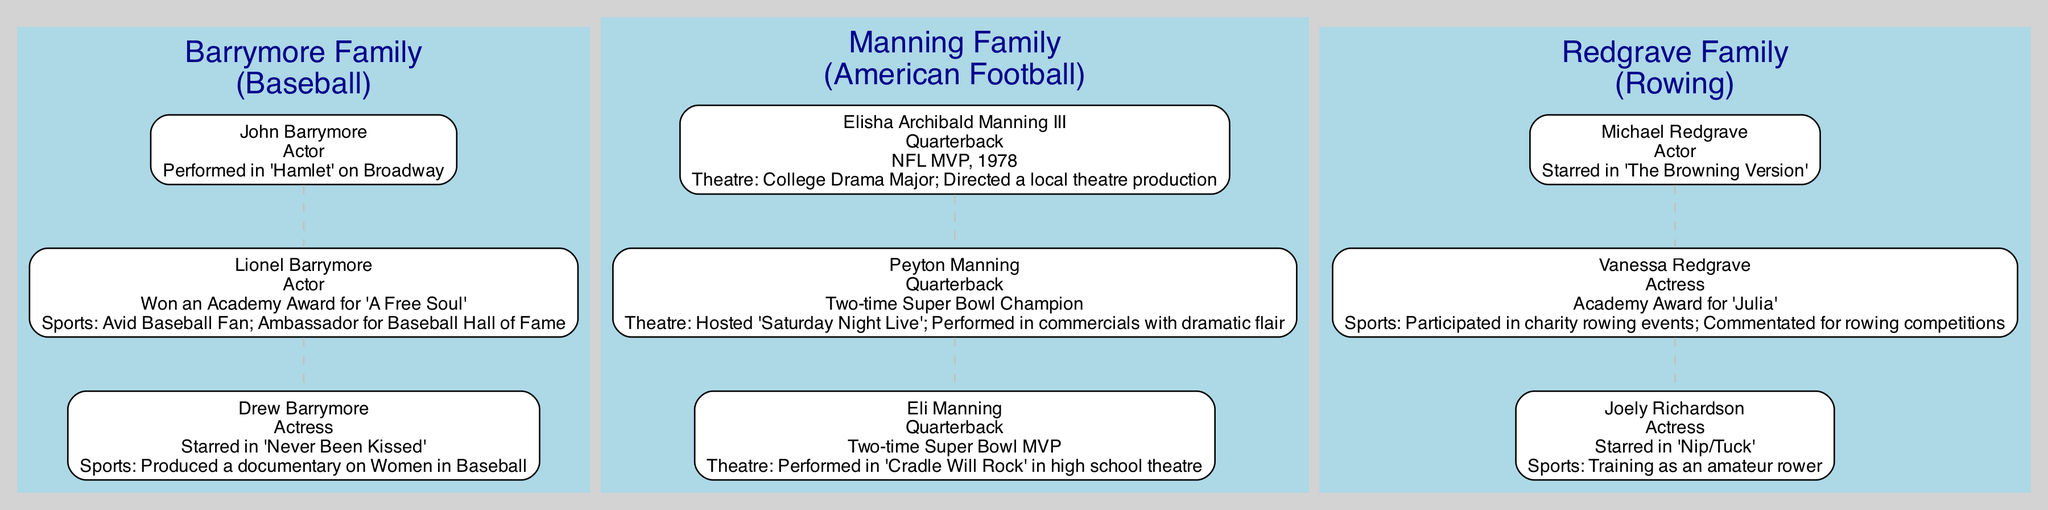What is the sports association of the Barrymore family? According to the diagram, the Barrymore family is associated with baseball, as clearly indicated in the family label.
Answer: Baseball Who is the actor who performed in 'Hamlet' on Broadway? The diagram specifies that John Barrymore is the actor who performed in 'Hamlet' on Broadway, making this information readily accessible.
Answer: John Barrymore How many members are there in the Manning family? The Manning family contains three members, which can be counted directly from the diagram nodes representing each family member.
Answer: 3 Which family member is associated with training as an amateur rower? Joely Richardson is the family member noted for training as an amateur rower according to the details in the diagram.
Answer: Joely Richardson Who won an Academy Award for 'Julia'? The diagram highlights that Vanessa Redgrave won an Academy Award for her role in 'Julia', providing a clear answer from her node.
Answer: Vanessa Redgrave What is Peyton Manning's theatrical connection? The diagram states that Peyton Manning hosted 'Saturday Night Live' and performed in commercials with dramatic flair, detailing his theatrical connection.
Answer: Hosted 'Saturday Night Live' Which family is associated with rowing? The Redgrave family is linked to rowing, as indicated in the family label within the diagram and the career highlights of its members.
Answer: Redgrave What is the role of Eli Manning? According to the diagram, Eli Manning's role is listed as Quarterback, providing direct information from his node.
Answer: Quarterback How many Academy Awards did Lionel Barrymore win? The diagram shows that Lionel Barrymore won one Academy Award for 'A Free Soul', which is specified in his details.
Answer: 1 